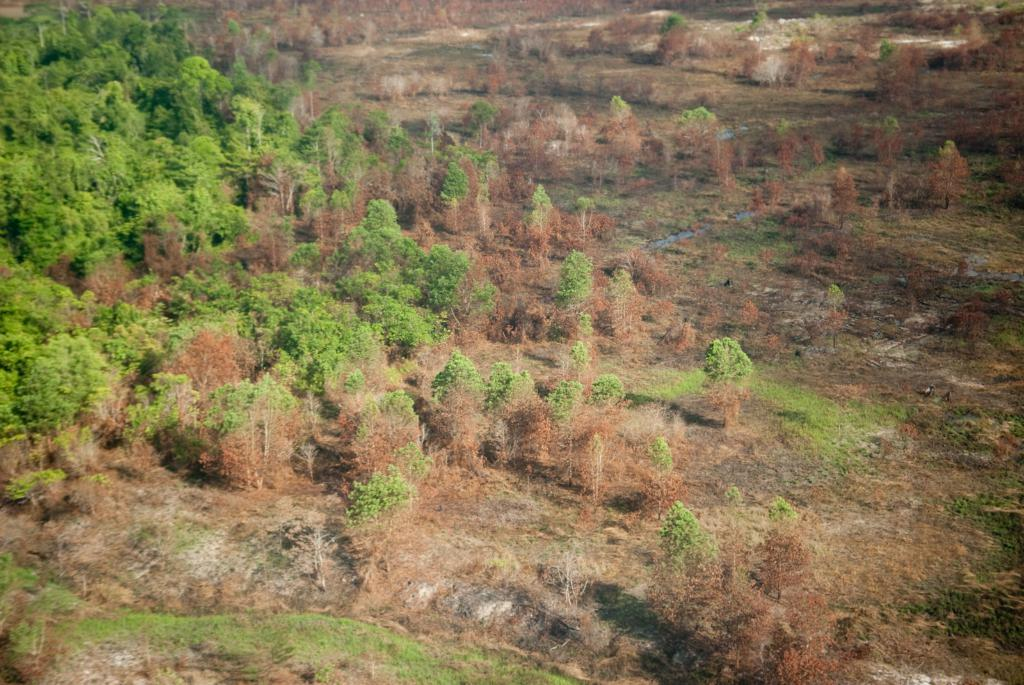What type of vegetation can be seen in the image? There are trees, plants, and grass visible in the image. What type of terrain is present in the image? There is land visible in the image. What type of prison can be seen in the image? There is no prison present in the image; it features trees, plants, grass, and land. What type of growth is visible on the trees in the image? The provided facts do not mention any specific growth on the trees, so we cannot determine that from the image. 